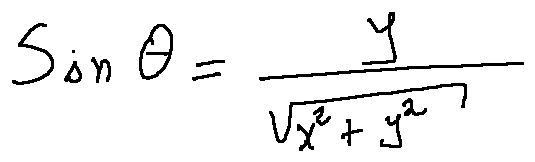Convert formula to latex. <formula><loc_0><loc_0><loc_500><loc_500>\sin \theta = \frac { y } { \sqrt { x ^ { 2 } + y ^ { 2 } } }</formula> 